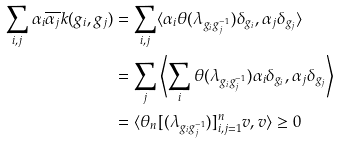<formula> <loc_0><loc_0><loc_500><loc_500>\sum _ { i , j } \alpha _ { i } \overline { \alpha _ { j } } k ( g _ { i } , g _ { j } ) & = \sum _ { i , j } \langle \alpha _ { i } \theta ( \lambda _ { g _ { i } g _ { j } ^ { - 1 } } ) \delta _ { g _ { i } } , \alpha _ { j } \delta _ { g _ { j } } \rangle \\ & = \sum _ { j } \left \langle \sum _ { i } \theta ( \lambda _ { g _ { i } g _ { j } ^ { - 1 } } ) \alpha _ { i } \delta _ { g _ { i } } , \alpha _ { j } \delta _ { g _ { j } } \right \rangle \\ & = \langle \theta _ { n } [ ( \lambda _ { g _ { i } g _ { j } ^ { - 1 } } ) ] _ { i , j = 1 } ^ { n } v , v \rangle \geq 0</formula> 